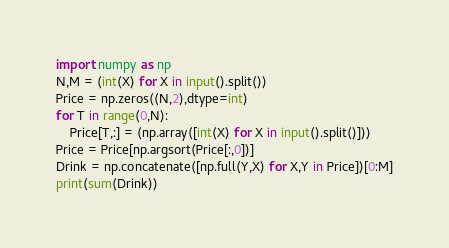<code> <loc_0><loc_0><loc_500><loc_500><_Python_>import numpy as np
N,M = (int(X) for X in input().split())
Price = np.zeros((N,2),dtype=int)
for T in range(0,N):
    Price[T,:] = (np.array([int(X) for X in input().split()]))
Price = Price[np.argsort(Price[:,0])]
Drink = np.concatenate([np.full(Y,X) for X,Y in Price])[0:M]
print(sum(Drink))</code> 